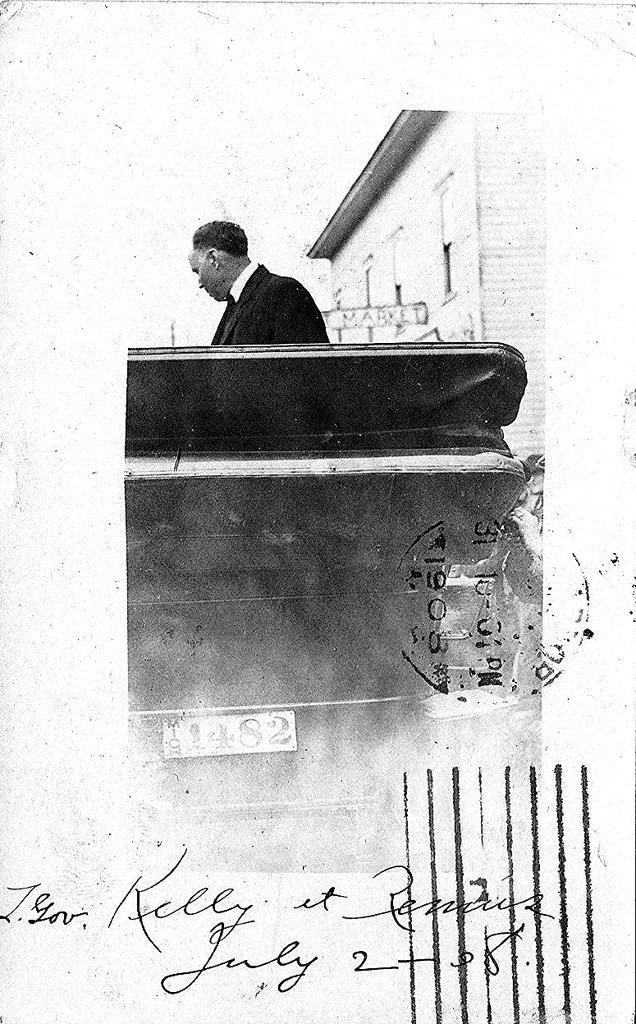Can you describe this image briefly? In this black and white image, we can see a person wearing clothes. There is a vehicle in the middle of the image. There is a roof house in the top right of the image. There is a written text at the bottom of the image. 